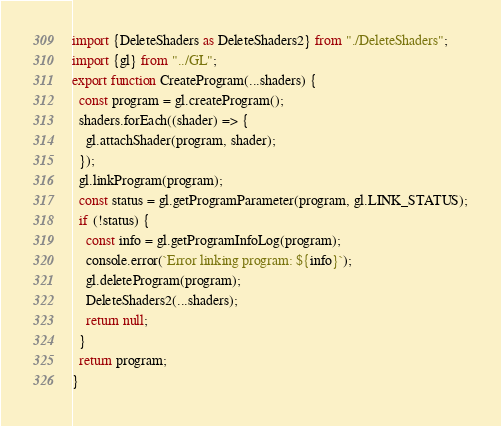Convert code to text. <code><loc_0><loc_0><loc_500><loc_500><_JavaScript_>import {DeleteShaders as DeleteShaders2} from "./DeleteShaders";
import {gl} from "../GL";
export function CreateProgram(...shaders) {
  const program = gl.createProgram();
  shaders.forEach((shader) => {
    gl.attachShader(program, shader);
  });
  gl.linkProgram(program);
  const status = gl.getProgramParameter(program, gl.LINK_STATUS);
  if (!status) {
    const info = gl.getProgramInfoLog(program);
    console.error(`Error linking program: ${info}`);
    gl.deleteProgram(program);
    DeleteShaders2(...shaders);
    return null;
  }
  return program;
}
</code> 